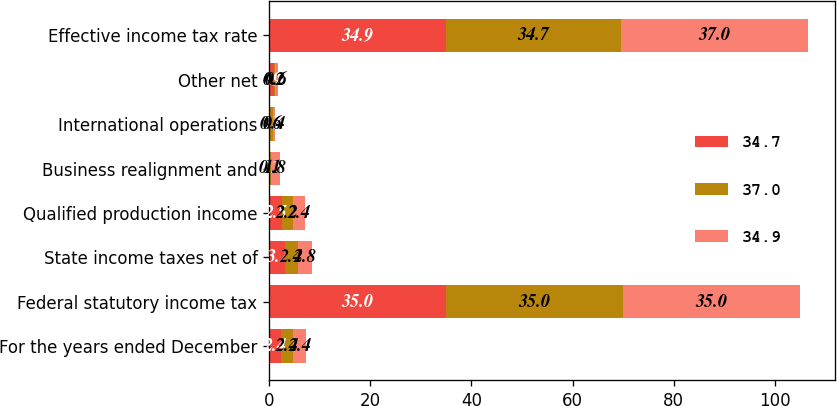<chart> <loc_0><loc_0><loc_500><loc_500><stacked_bar_chart><ecel><fcel>For the years ended December<fcel>Federal statutory income tax<fcel>State income taxes net of<fcel>Qualified production income<fcel>Business realignment and<fcel>International operations<fcel>Other net<fcel>Effective income tax rate<nl><fcel>34.7<fcel>2.4<fcel>35<fcel>3.2<fcel>2.5<fcel>0.2<fcel>0.1<fcel>0.9<fcel>34.9<nl><fcel>37<fcel>2.4<fcel>35<fcel>2.4<fcel>2.2<fcel>0.1<fcel>0.6<fcel>0.2<fcel>34.7<nl><fcel>34.9<fcel>2.4<fcel>35<fcel>2.8<fcel>2.4<fcel>1.8<fcel>0.4<fcel>0.6<fcel>37<nl></chart> 